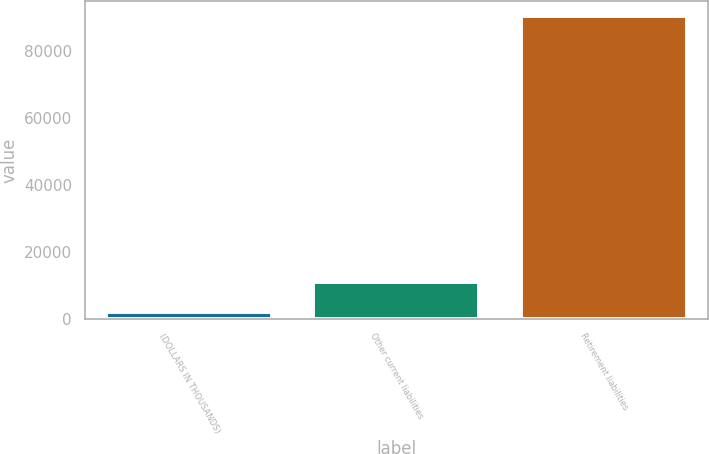Convert chart. <chart><loc_0><loc_0><loc_500><loc_500><bar_chart><fcel>(DOLLARS IN THOUSANDS)<fcel>Other current liabilities<fcel>Retirement liabilities<nl><fcel>2010<fcel>10836.1<fcel>90271<nl></chart> 